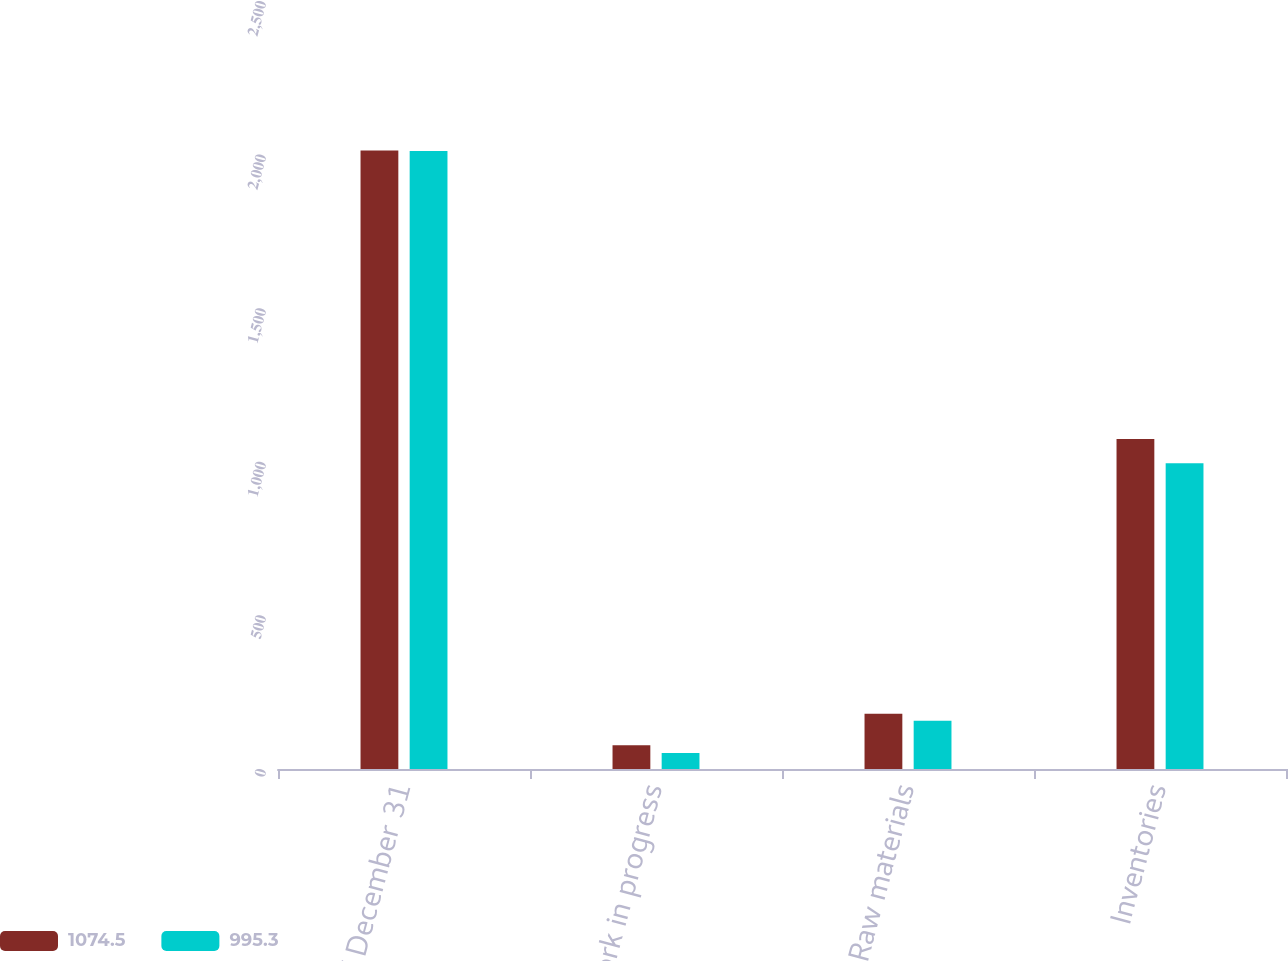Convert chart to OTSL. <chart><loc_0><loc_0><loc_500><loc_500><stacked_bar_chart><ecel><fcel>As of December 31<fcel>Work in progress<fcel>Raw materials<fcel>Inventories<nl><fcel>1074.5<fcel>2013<fcel>77.4<fcel>180.1<fcel>1074.5<nl><fcel>995.3<fcel>2012<fcel>52.3<fcel>156.7<fcel>995.3<nl></chart> 